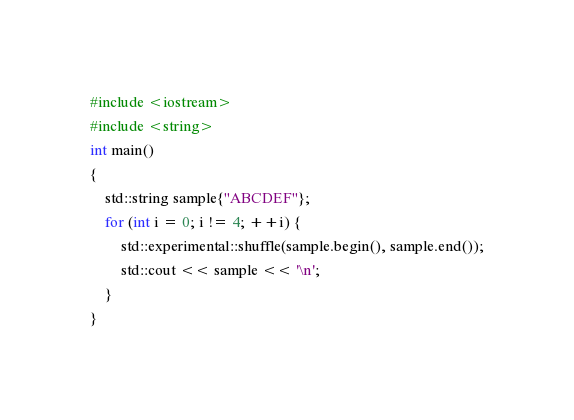<code> <loc_0><loc_0><loc_500><loc_500><_C++_>#include <iostream>
#include <string>
int main()
{
    std::string sample{"ABCDEF"};
    for (int i = 0; i != 4; ++i) {
        std::experimental::shuffle(sample.begin(), sample.end());
        std::cout << sample << '\n';
    }
}

</code> 